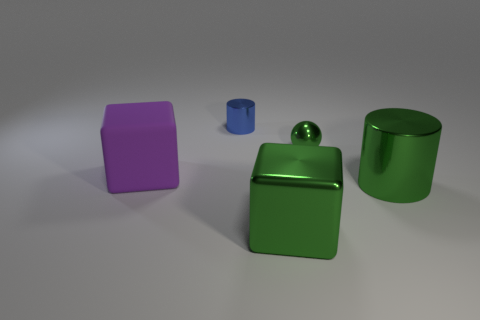Add 4 tiny green spheres. How many objects exist? 9 Subtract all blocks. How many objects are left? 3 Add 3 purple rubber cylinders. How many purple rubber cylinders exist? 3 Subtract 0 blue blocks. How many objects are left? 5 Subtract all shiny cubes. Subtract all large shiny cylinders. How many objects are left? 3 Add 5 small green metallic spheres. How many small green metallic spheres are left? 6 